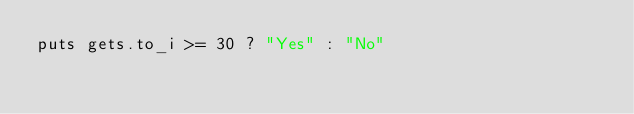<code> <loc_0><loc_0><loc_500><loc_500><_Ruby_>puts gets.to_i >= 30 ? "Yes" : "No"
</code> 